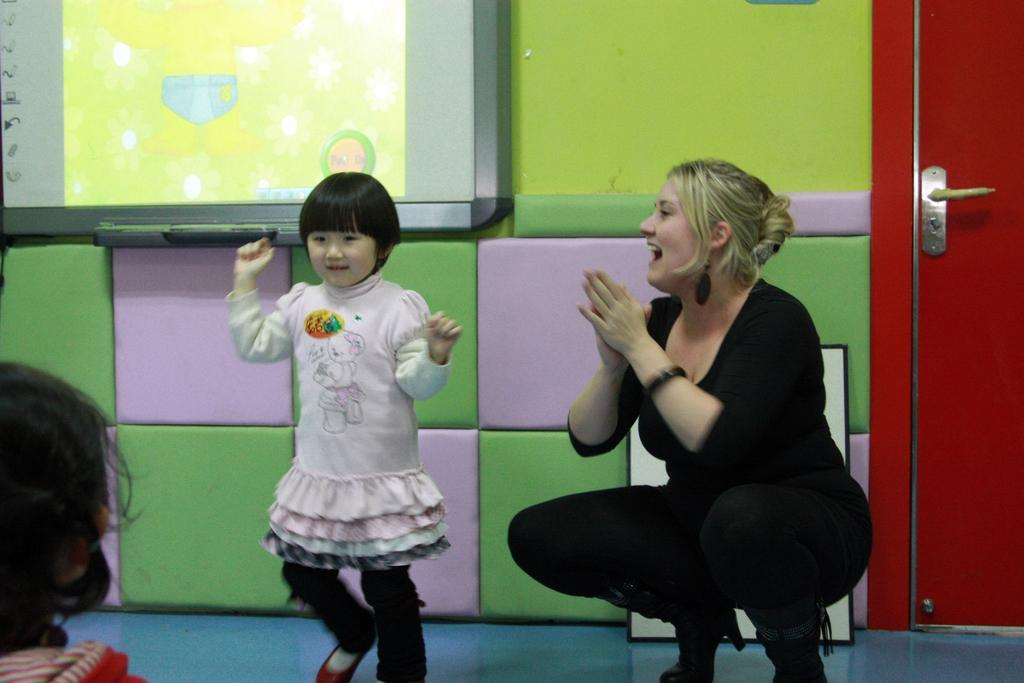How would you summarize this image in a sentence or two? On the right side of the image we can see a lady sitting and smiling, next to her there is a girl. In the background we can see a screen placed on the wall. There is a door. On the left there is a person. 